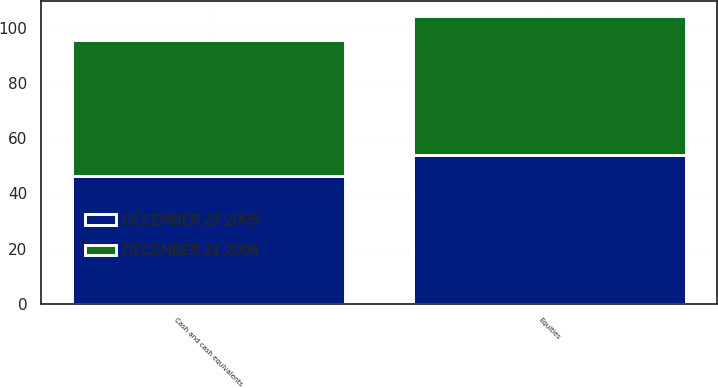<chart> <loc_0><loc_0><loc_500><loc_500><stacked_bar_chart><ecel><fcel>Equities<fcel>Cash and cash equivalents<nl><fcel>DECEMBER 25 2005<fcel>53.8<fcel>46.2<nl><fcel>DECEMBER 31 2006<fcel>50.6<fcel>49.4<nl></chart> 